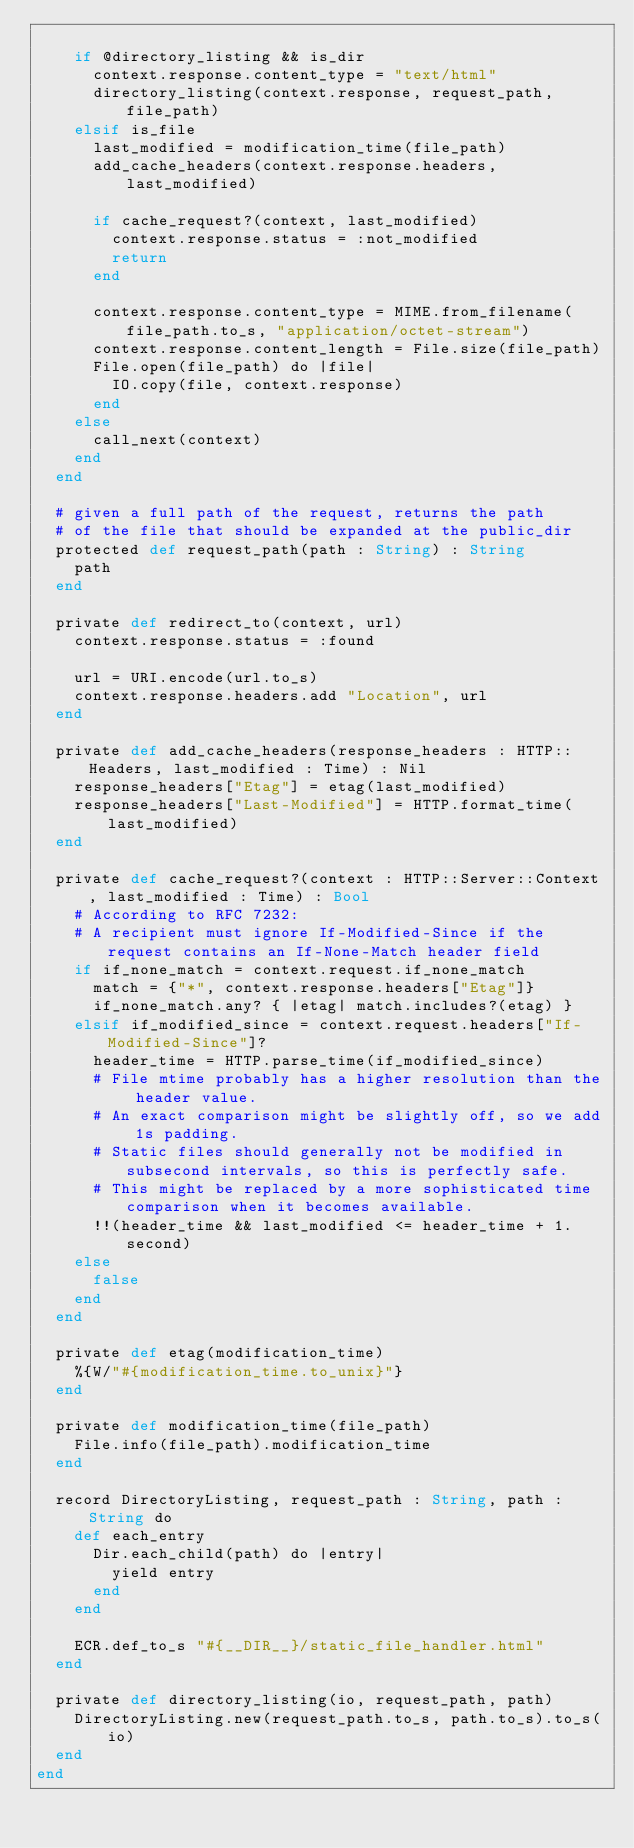Convert code to text. <code><loc_0><loc_0><loc_500><loc_500><_Crystal_>
    if @directory_listing && is_dir
      context.response.content_type = "text/html"
      directory_listing(context.response, request_path, file_path)
    elsif is_file
      last_modified = modification_time(file_path)
      add_cache_headers(context.response.headers, last_modified)

      if cache_request?(context, last_modified)
        context.response.status = :not_modified
        return
      end

      context.response.content_type = MIME.from_filename(file_path.to_s, "application/octet-stream")
      context.response.content_length = File.size(file_path)
      File.open(file_path) do |file|
        IO.copy(file, context.response)
      end
    else
      call_next(context)
    end
  end

  # given a full path of the request, returns the path
  # of the file that should be expanded at the public_dir
  protected def request_path(path : String) : String
    path
  end

  private def redirect_to(context, url)
    context.response.status = :found

    url = URI.encode(url.to_s)
    context.response.headers.add "Location", url
  end

  private def add_cache_headers(response_headers : HTTP::Headers, last_modified : Time) : Nil
    response_headers["Etag"] = etag(last_modified)
    response_headers["Last-Modified"] = HTTP.format_time(last_modified)
  end

  private def cache_request?(context : HTTP::Server::Context, last_modified : Time) : Bool
    # According to RFC 7232:
    # A recipient must ignore If-Modified-Since if the request contains an If-None-Match header field
    if if_none_match = context.request.if_none_match
      match = {"*", context.response.headers["Etag"]}
      if_none_match.any? { |etag| match.includes?(etag) }
    elsif if_modified_since = context.request.headers["If-Modified-Since"]?
      header_time = HTTP.parse_time(if_modified_since)
      # File mtime probably has a higher resolution than the header value.
      # An exact comparison might be slightly off, so we add 1s padding.
      # Static files should generally not be modified in subsecond intervals, so this is perfectly safe.
      # This might be replaced by a more sophisticated time comparison when it becomes available.
      !!(header_time && last_modified <= header_time + 1.second)
    else
      false
    end
  end

  private def etag(modification_time)
    %{W/"#{modification_time.to_unix}"}
  end

  private def modification_time(file_path)
    File.info(file_path).modification_time
  end

  record DirectoryListing, request_path : String, path : String do
    def each_entry
      Dir.each_child(path) do |entry|
        yield entry
      end
    end

    ECR.def_to_s "#{__DIR__}/static_file_handler.html"
  end

  private def directory_listing(io, request_path, path)
    DirectoryListing.new(request_path.to_s, path.to_s).to_s(io)
  end
end
</code> 